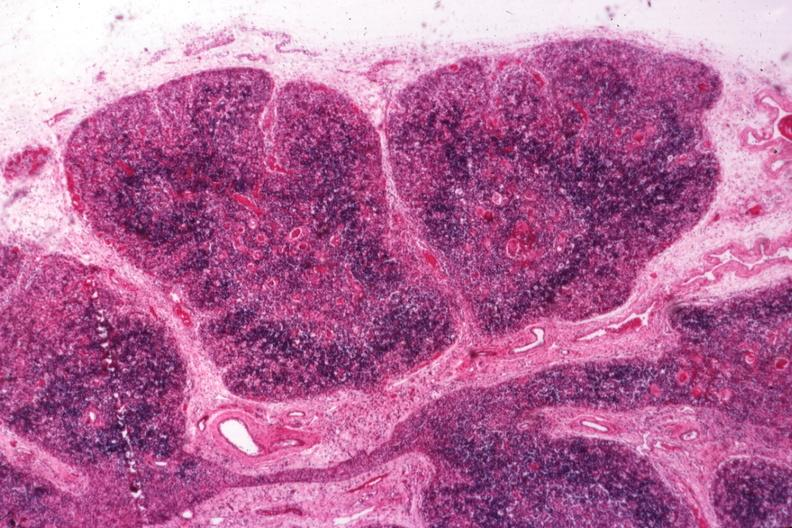what associated with infection in newborn?
Answer the question using a single word or phrase. Typical atrophy 